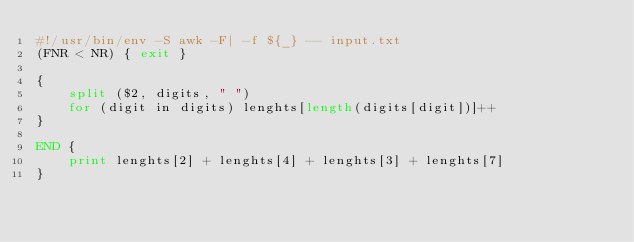Convert code to text. <code><loc_0><loc_0><loc_500><loc_500><_Awk_>#!/usr/bin/env -S awk -F| -f ${_} -- input.txt
(FNR < NR) { exit }

{
    split ($2, digits, " ")
    for (digit in digits) lenghts[length(digits[digit])]++
}

END {
    print lenghts[2] + lenghts[4] + lenghts[3] + lenghts[7]
}
</code> 